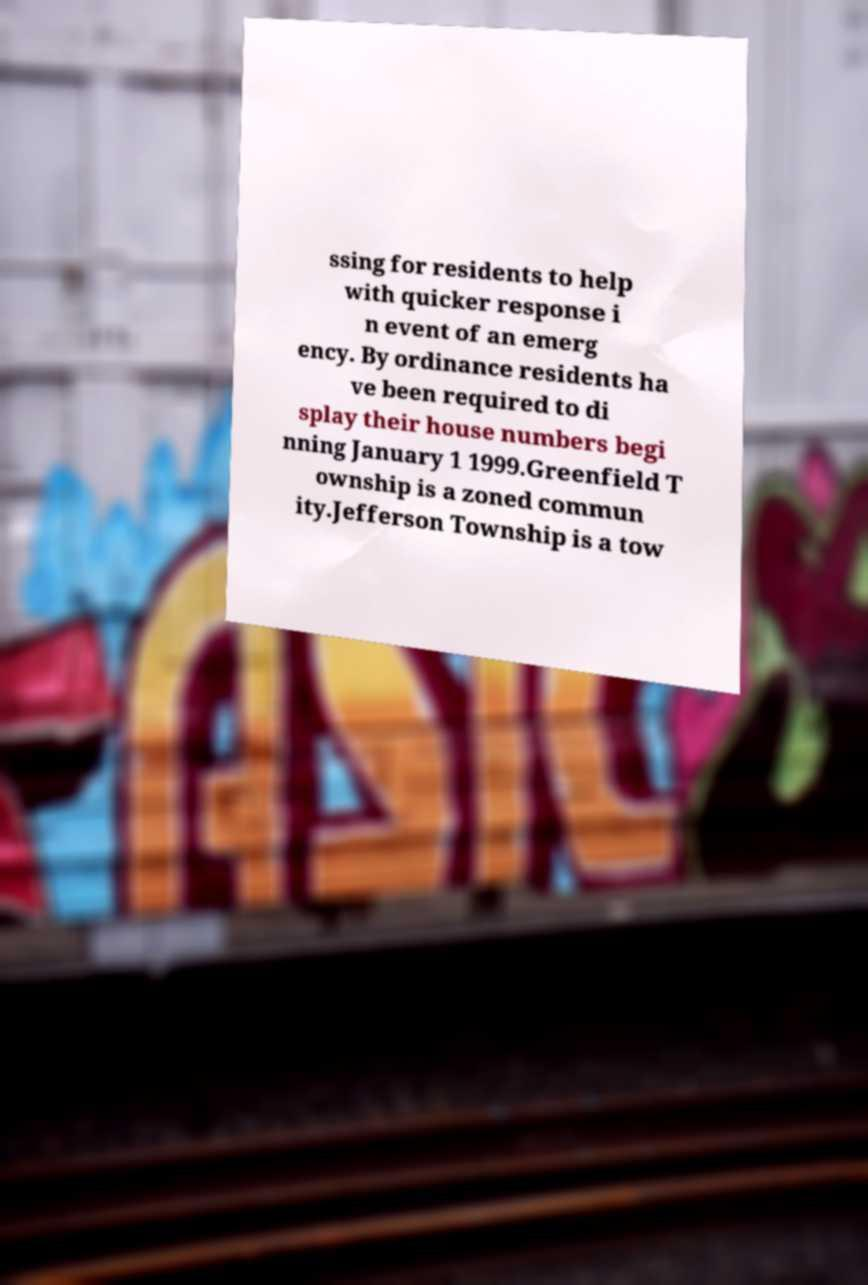Could you assist in decoding the text presented in this image and type it out clearly? ssing for residents to help with quicker response i n event of an emerg ency. By ordinance residents ha ve been required to di splay their house numbers begi nning January 1 1999.Greenfield T ownship is a zoned commun ity.Jefferson Township is a tow 